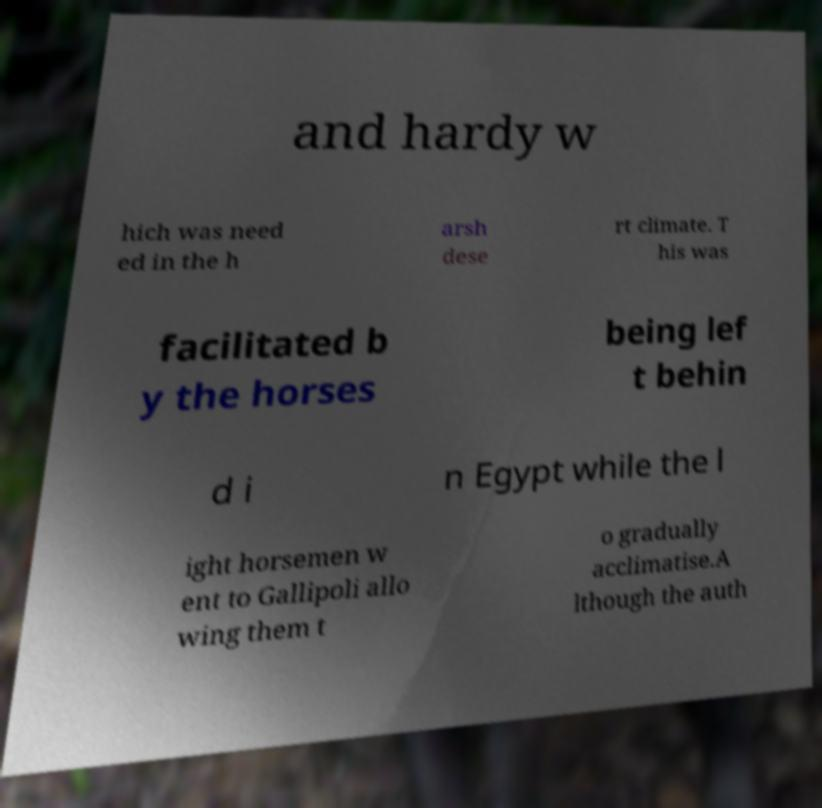Can you read and provide the text displayed in the image?This photo seems to have some interesting text. Can you extract and type it out for me? and hardy w hich was need ed in the h arsh dese rt climate. T his was facilitated b y the horses being lef t behin d i n Egypt while the l ight horsemen w ent to Gallipoli allo wing them t o gradually acclimatise.A lthough the auth 